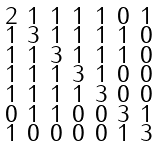Convert formula to latex. <formula><loc_0><loc_0><loc_500><loc_500>\begin{smallmatrix} 2 & 1 & 1 & 1 & 1 & 0 & 1 \\ 1 & 3 & 1 & 1 & 1 & 1 & 0 \\ 1 & 1 & 3 & 1 & 1 & 1 & 0 \\ 1 & 1 & 1 & 3 & 1 & 0 & 0 \\ 1 & 1 & 1 & 1 & 3 & 0 & 0 \\ 0 & 1 & 1 & 0 & 0 & 3 & 1 \\ 1 & 0 & 0 & 0 & 0 & 1 & 3 \end{smallmatrix}</formula> 